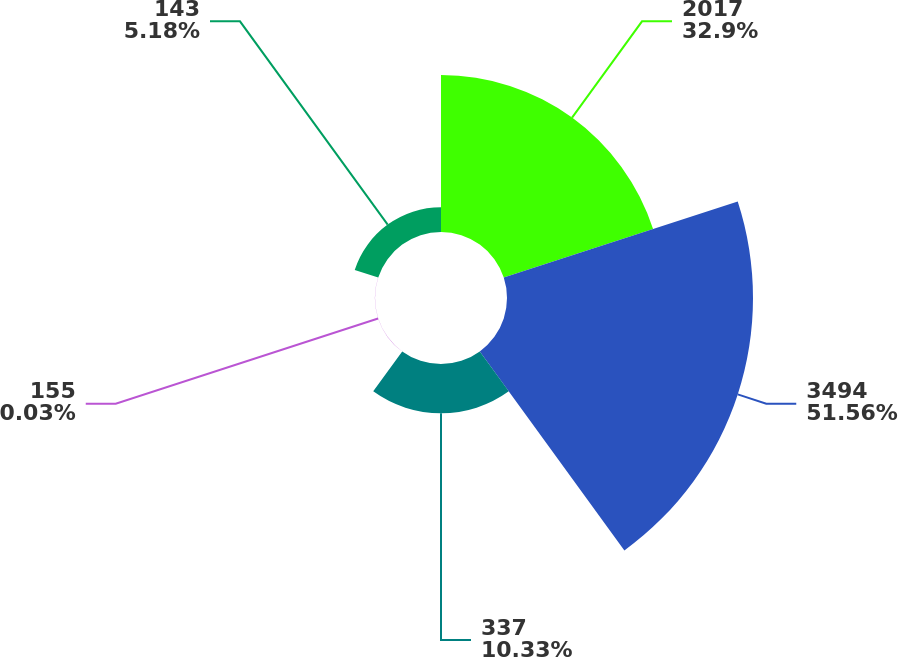Convert chart to OTSL. <chart><loc_0><loc_0><loc_500><loc_500><pie_chart><fcel>2017<fcel>3494<fcel>337<fcel>155<fcel>143<nl><fcel>32.9%<fcel>51.55%<fcel>10.33%<fcel>0.03%<fcel>5.18%<nl></chart> 